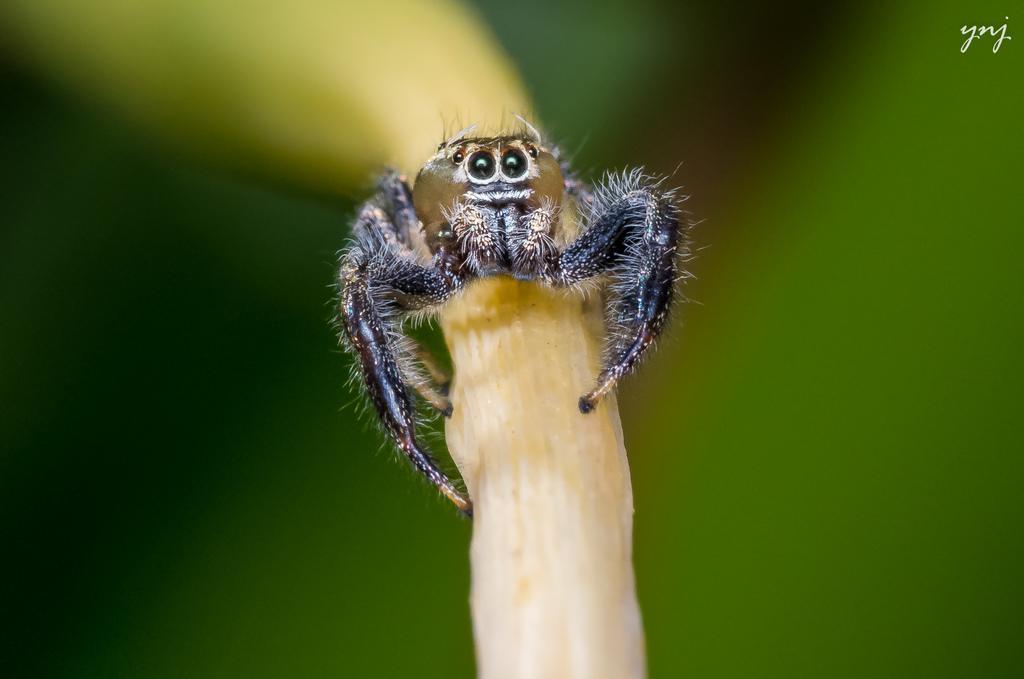Please provide a concise description of this image. In this image there is an insect on an object. Background is blurry. 